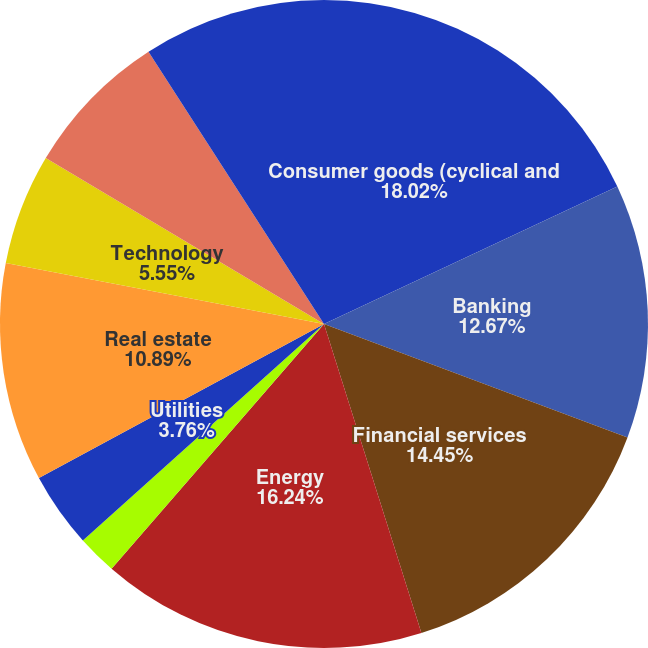Convert chart to OTSL. <chart><loc_0><loc_0><loc_500><loc_500><pie_chart><fcel>Consumer goods (cyclical and<fcel>Banking<fcel>Financial services<fcel>Energy<fcel>Basic industry<fcel>Utilities<fcel>Real estate<fcel>Technology<fcel>Capital goods<fcel>Communications<nl><fcel>18.02%<fcel>12.67%<fcel>14.45%<fcel>16.24%<fcel>1.98%<fcel>3.76%<fcel>10.89%<fcel>5.55%<fcel>7.33%<fcel>9.11%<nl></chart> 